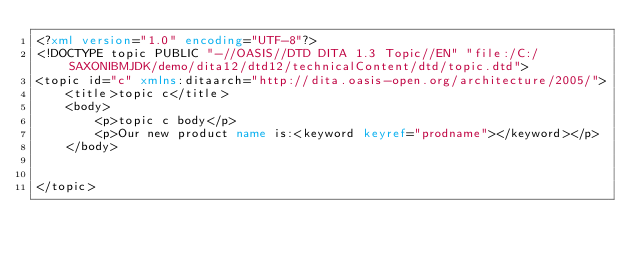Convert code to text. <code><loc_0><loc_0><loc_500><loc_500><_XML_><?xml version="1.0" encoding="UTF-8"?>
<!DOCTYPE topic PUBLIC "-//OASIS//DTD DITA 1.3 Topic//EN" "file:/C:/SAXONIBMJDK/demo/dita12/dtd12/technicalContent/dtd/topic.dtd">
<topic id="c" xmlns:ditaarch="http://dita.oasis-open.org/architecture/2005/">
    <title>topic c</title>
    <body>
        <p>topic c body</p>
        <p>Our new product name is:<keyword keyref="prodname"></keyword></p>
    </body>

    
</topic></code> 